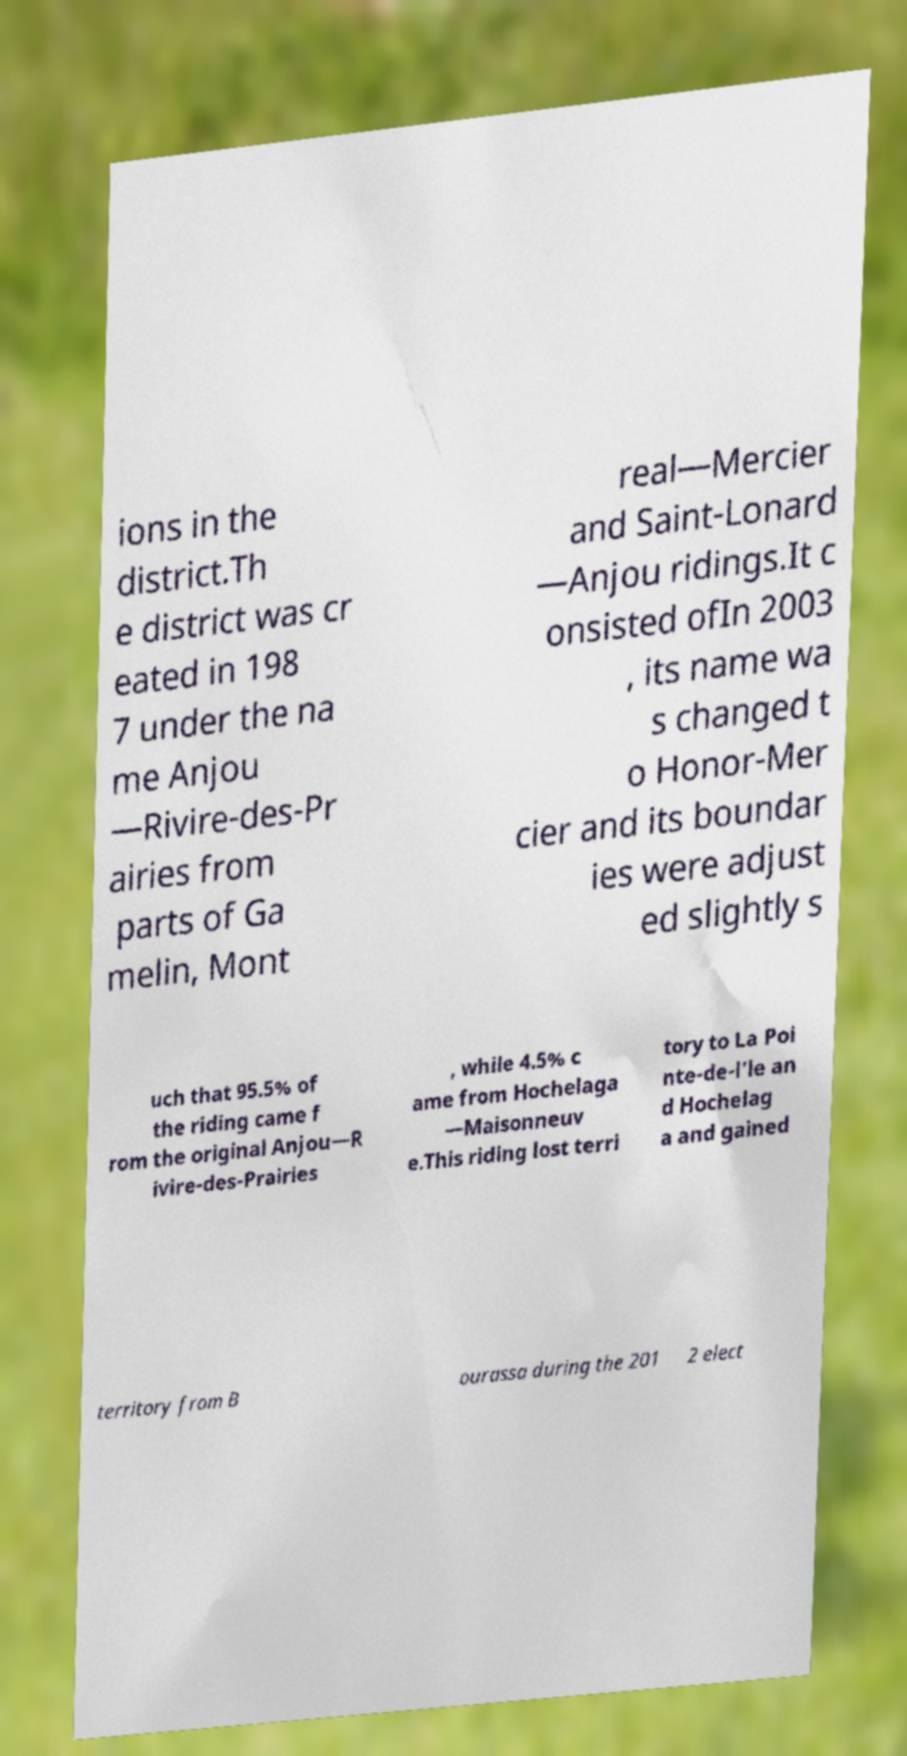I need the written content from this picture converted into text. Can you do that? ions in the district.Th e district was cr eated in 198 7 under the na me Anjou —Rivire-des-Pr airies from parts of Ga melin, Mont real—Mercier and Saint-Lonard —Anjou ridings.It c onsisted ofIn 2003 , its name wa s changed t o Honor-Mer cier and its boundar ies were adjust ed slightly s uch that 95.5% of the riding came f rom the original Anjou—R ivire-des-Prairies , while 4.5% c ame from Hochelaga —Maisonneuv e.This riding lost terri tory to La Poi nte-de-l'le an d Hochelag a and gained territory from B ourassa during the 201 2 elect 